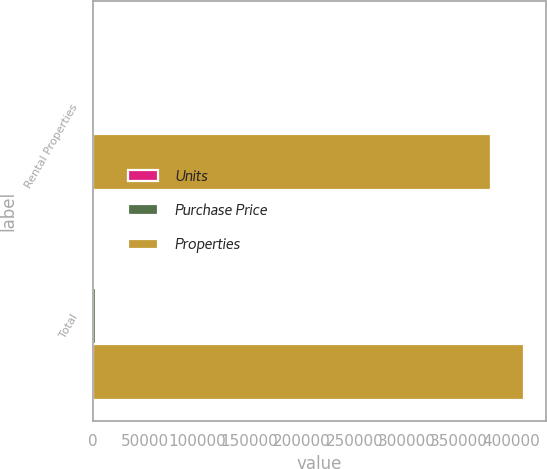Convert chart to OTSL. <chart><loc_0><loc_0><loc_500><loc_500><stacked_bar_chart><ecel><fcel>Rental Properties<fcel>Total<nl><fcel>Units<fcel>7<fcel>8<nl><fcel>Purchase Price<fcel>2141<fcel>3119<nl><fcel>Properties<fcel>380683<fcel>412388<nl></chart> 